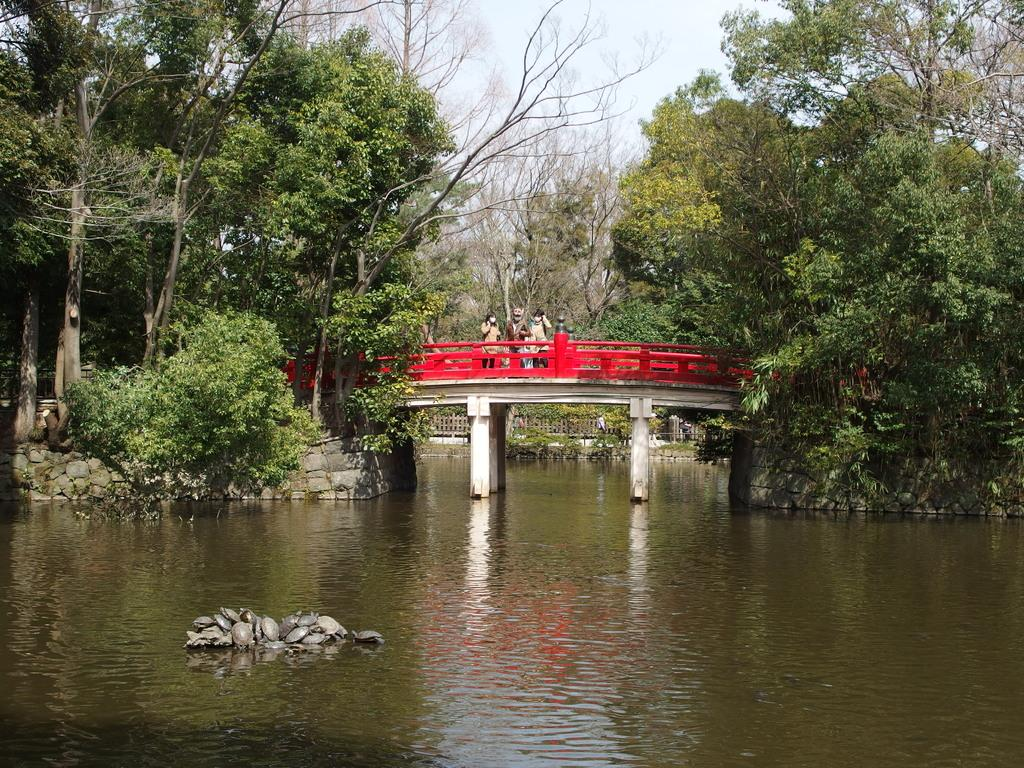What is the main feature in the foreground of the image? There is a water body in the foreground of the image. What can be seen in the background of the image? There are trees, stones, a fence, and a bridge in the background of the image. What is the bridge used for in the image? There are people on the bridge, suggesting it is used for crossing the water body. What type of art can be seen hanging on the plot in the image? There is no plot or art present in the image. The image features a water body, trees, stones, a fence, a bridge, and people on the bridge. 